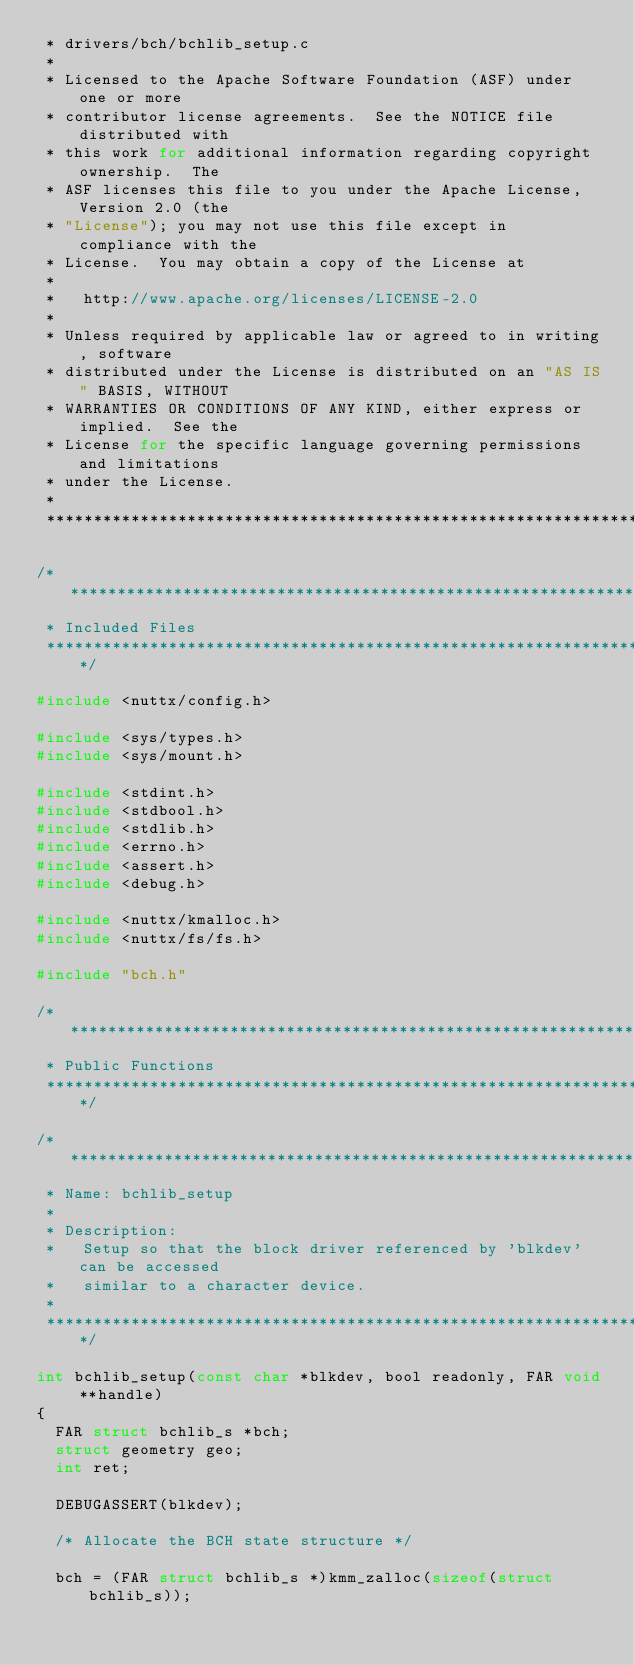Convert code to text. <code><loc_0><loc_0><loc_500><loc_500><_C_> * drivers/bch/bchlib_setup.c
 *
 * Licensed to the Apache Software Foundation (ASF) under one or more
 * contributor license agreements.  See the NOTICE file distributed with
 * this work for additional information regarding copyright ownership.  The
 * ASF licenses this file to you under the Apache License, Version 2.0 (the
 * "License"); you may not use this file except in compliance with the
 * License.  You may obtain a copy of the License at
 *
 *   http://www.apache.org/licenses/LICENSE-2.0
 *
 * Unless required by applicable law or agreed to in writing, software
 * distributed under the License is distributed on an "AS IS" BASIS, WITHOUT
 * WARRANTIES OR CONDITIONS OF ANY KIND, either express or implied.  See the
 * License for the specific language governing permissions and limitations
 * under the License.
 *
 ****************************************************************************/

/****************************************************************************
 * Included Files
 ****************************************************************************/

#include <nuttx/config.h>

#include <sys/types.h>
#include <sys/mount.h>

#include <stdint.h>
#include <stdbool.h>
#include <stdlib.h>
#include <errno.h>
#include <assert.h>
#include <debug.h>

#include <nuttx/kmalloc.h>
#include <nuttx/fs/fs.h>

#include "bch.h"

/****************************************************************************
 * Public Functions
 ****************************************************************************/

/****************************************************************************
 * Name: bchlib_setup
 *
 * Description:
 *   Setup so that the block driver referenced by 'blkdev' can be accessed
 *   similar to a character device.
 *
 ****************************************************************************/

int bchlib_setup(const char *blkdev, bool readonly, FAR void **handle)
{
  FAR struct bchlib_s *bch;
  struct geometry geo;
  int ret;

  DEBUGASSERT(blkdev);

  /* Allocate the BCH state structure */

  bch = (FAR struct bchlib_s *)kmm_zalloc(sizeof(struct bchlib_s));</code> 